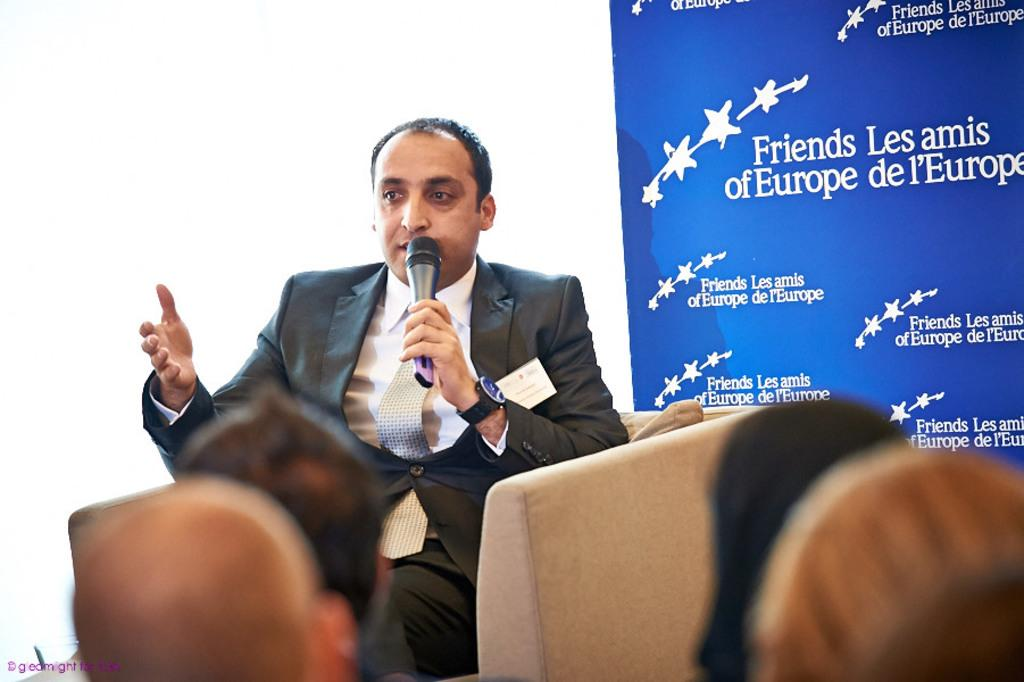What is the man in the image doing? The man is sitting on a sofa and speaking into a microphone. What is the man wearing in the image? The man is wearing a coat, a tie, and a shirt. What can be seen on the right side of the image? There is a blue banner on the right side of the image. What is the man's position in relation to the sofa? The man is sitting on the sofa. What type of crayon is the man using to draw on the boundary in the image? There is no crayon or boundary present in the image. How does the man use the hammer to communicate with the audience in the image? There is no hammer present in the image, and the man is speaking into a microphone, not using a hammer to communicate. 